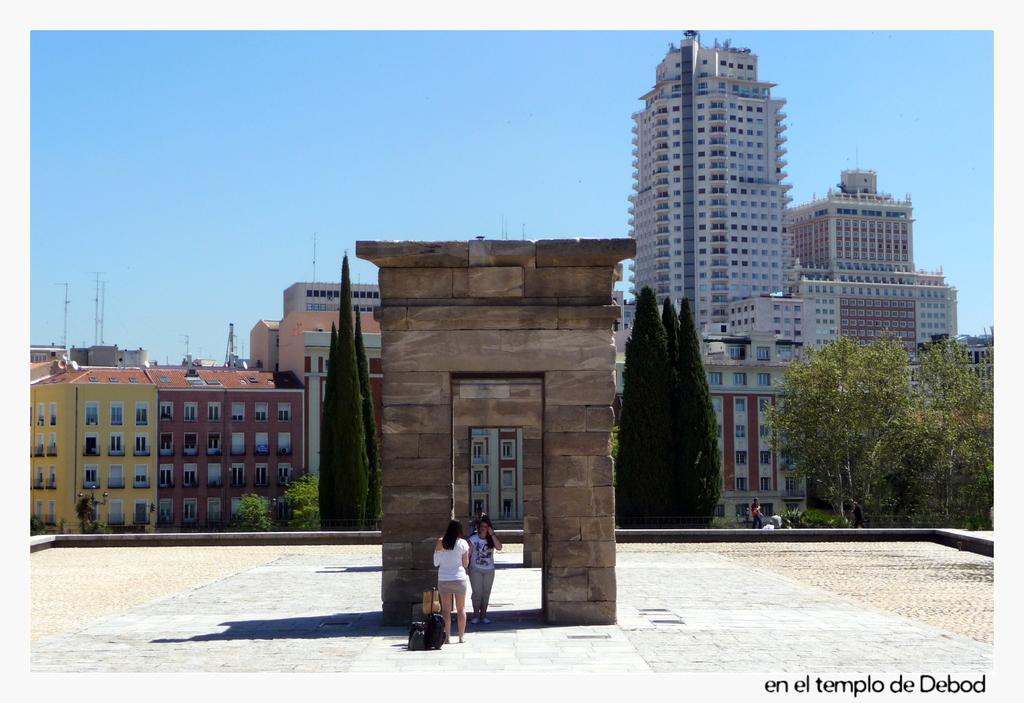Can you describe this image briefly? In this image we can see two women standing on the ground. In the background we can see group of trees ,buildings ,a person and sky. 